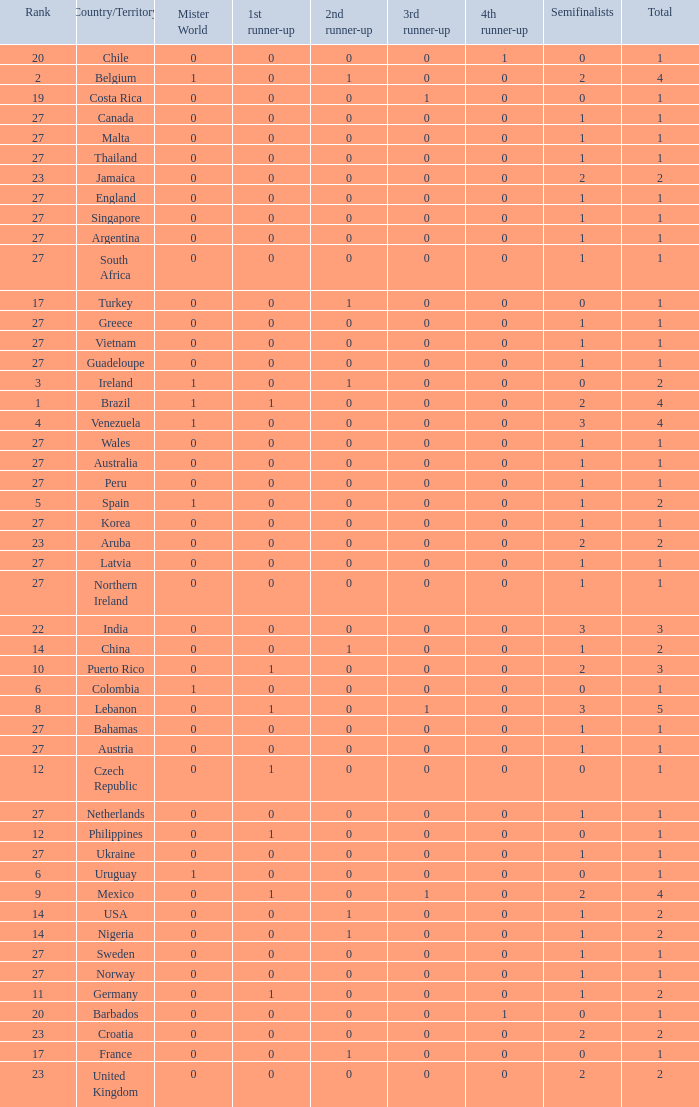What is the tiniest 1st runner up value? 0.0. 